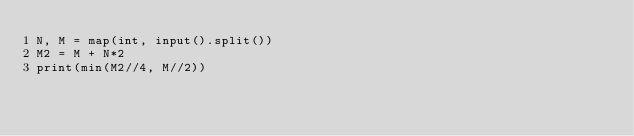Convert code to text. <code><loc_0><loc_0><loc_500><loc_500><_Python_>N, M = map(int, input().split())
M2 = M + N*2
print(min(M2//4, M//2))</code> 